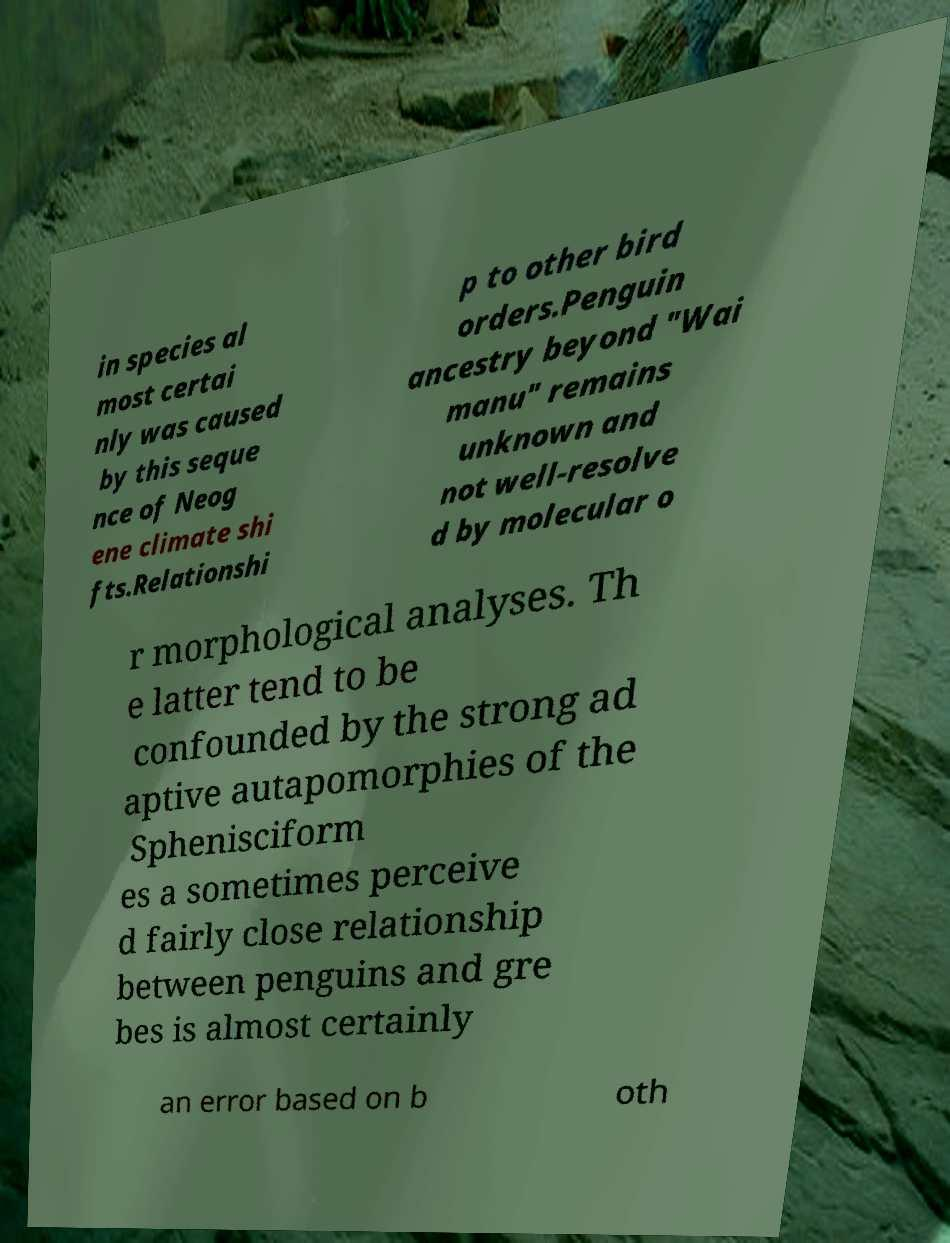Please identify and transcribe the text found in this image. in species al most certai nly was caused by this seque nce of Neog ene climate shi fts.Relationshi p to other bird orders.Penguin ancestry beyond "Wai manu" remains unknown and not well-resolve d by molecular o r morphological analyses. Th e latter tend to be confounded by the strong ad aptive autapomorphies of the Sphenisciform es a sometimes perceive d fairly close relationship between penguins and gre bes is almost certainly an error based on b oth 